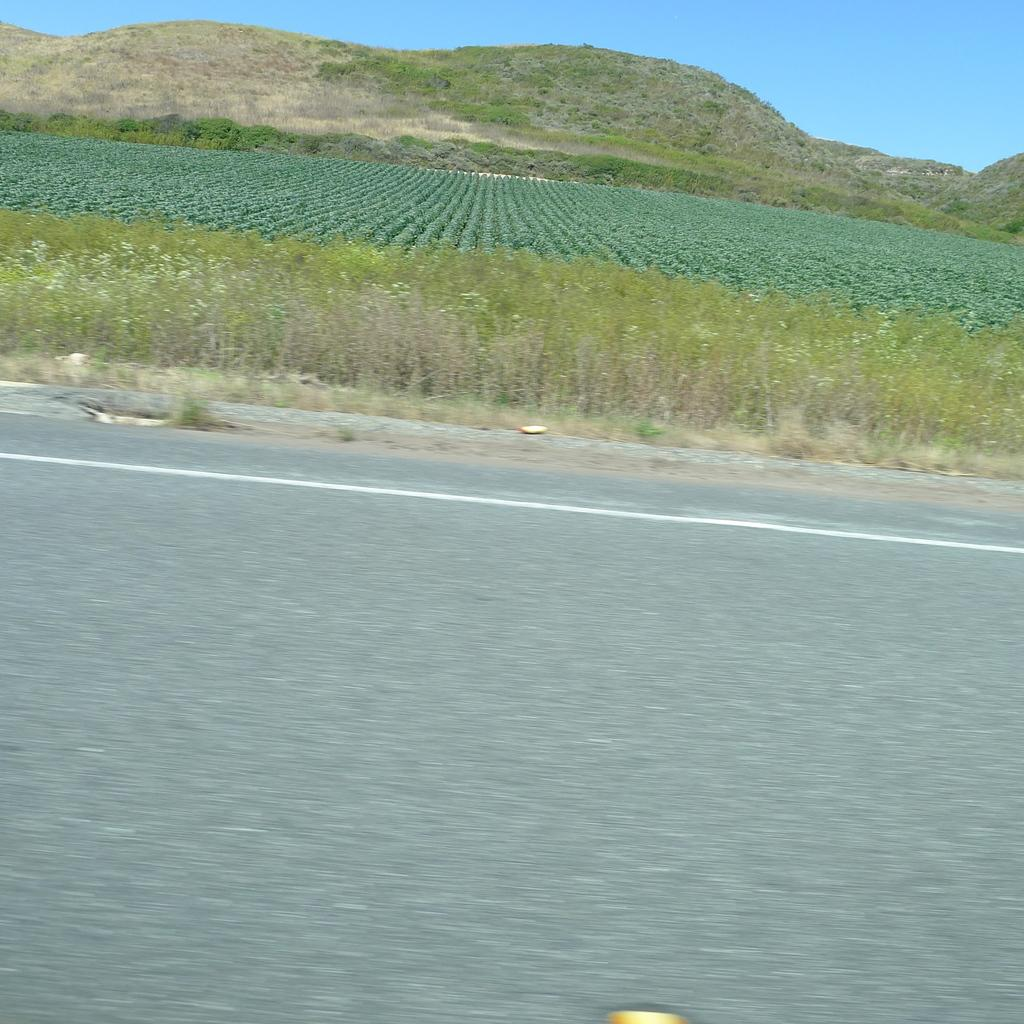What type of terrain is visible in the image? The ground is visible in the image, and there is grass and plants present. Are there any elevated features in the image? Yes, there are hills in the image. What part of the natural environment is visible in the image? The sky is visible in the image. What type of pan can be seen cooking over the grass in the image? There is no pan or cooking activity present in the image; it features grass, plants, hills, and the sky. 